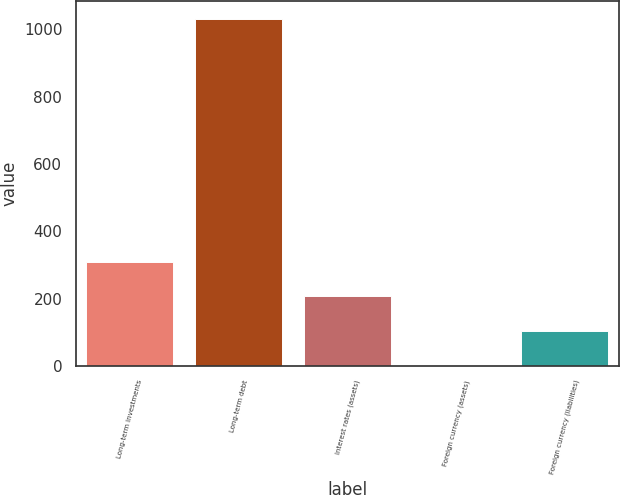Convert chart to OTSL. <chart><loc_0><loc_0><loc_500><loc_500><bar_chart><fcel>Long-term investments<fcel>Long-term debt<fcel>Interest rates (assets)<fcel>Foreign currency (assets)<fcel>Foreign currency (liabilities)<nl><fcel>310.08<fcel>1031.5<fcel>207.02<fcel>0.9<fcel>103.96<nl></chart> 